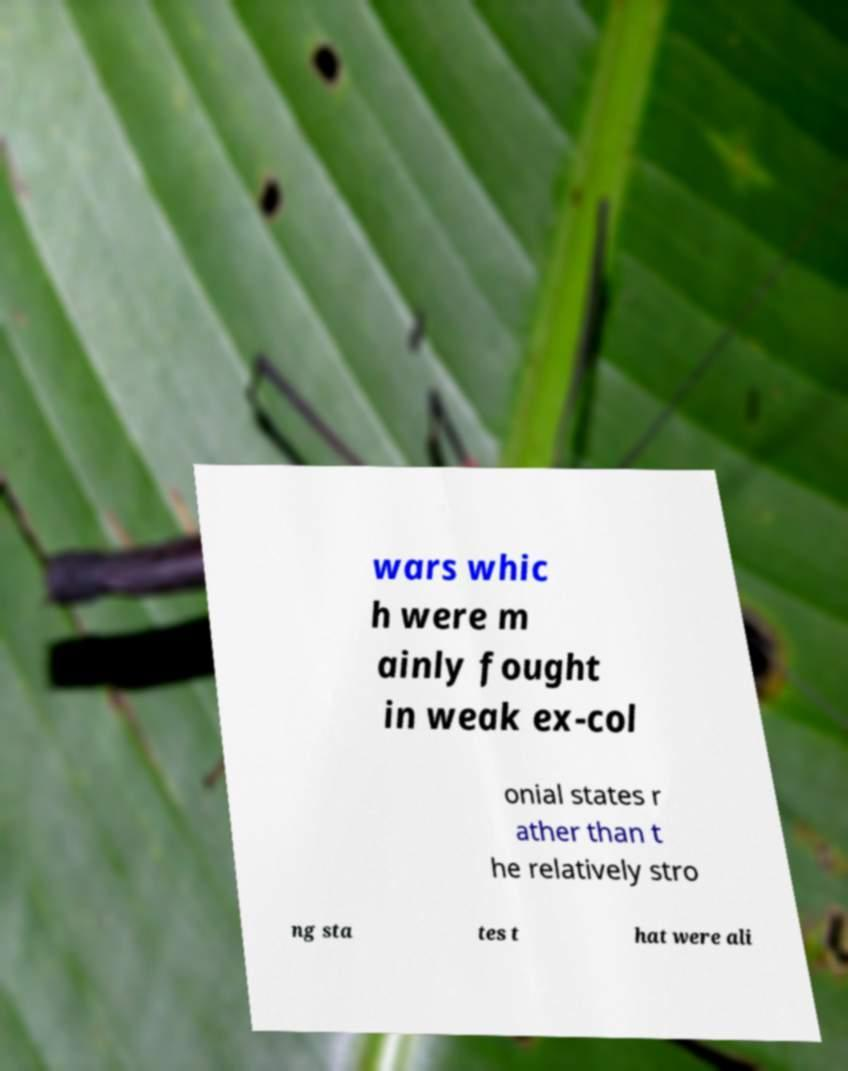Can you read and provide the text displayed in the image?This photo seems to have some interesting text. Can you extract and type it out for me? wars whic h were m ainly fought in weak ex-col onial states r ather than t he relatively stro ng sta tes t hat were ali 